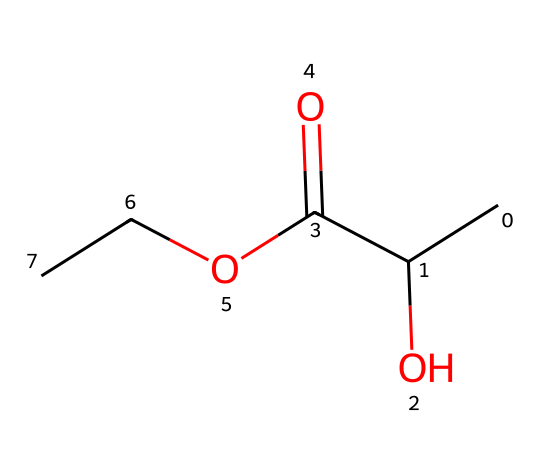What is the total number of carbon atoms in this solvent? The SMILES representation shows that there are three carbon atoms in the chain: one from the CC group before the hydroxyl (-OH) and two from the ester part (OCC).
Answer: three How many oxygen atoms are present in this chemical structure? Analyzing the SMILES, there are two oxygen atoms; one in the hydroxyl (-OH) group and one in the carbonyl (C=O) and another in the ethyl (OCC) part.
Answer: three Is this chemical likely to be hydrophilic or hydrophobic? The presence of hydroxyl (-OH) and carboxylic (-COOH) functional groups suggests that the molecule can form hydrogen bonds with water, indicating hydrophilicity.
Answer: hydrophilic What is the functional group associated with the ester portion of this molecule? The -OCC part indicates that this molecule contains an ester functional group, as it's derived from alcohol (-OH) and carboxylic acid (C=O and -COOH).
Answer: ester Does this solvent have biodegradable properties based on its structure? The inclusion of hydroxyl (-OH) and carboxylic acid (-COOH) functional groups often suggests that it can be broken down by natural processes, indicating biodegradability.
Answer: yes What type of reaction would primarily be involved in synthesizing this solvent? The functional groups and structure suggest that it is synthesized via esterification, which is a reaction between an alcohol and a carboxylic acid.
Answer: esterification 